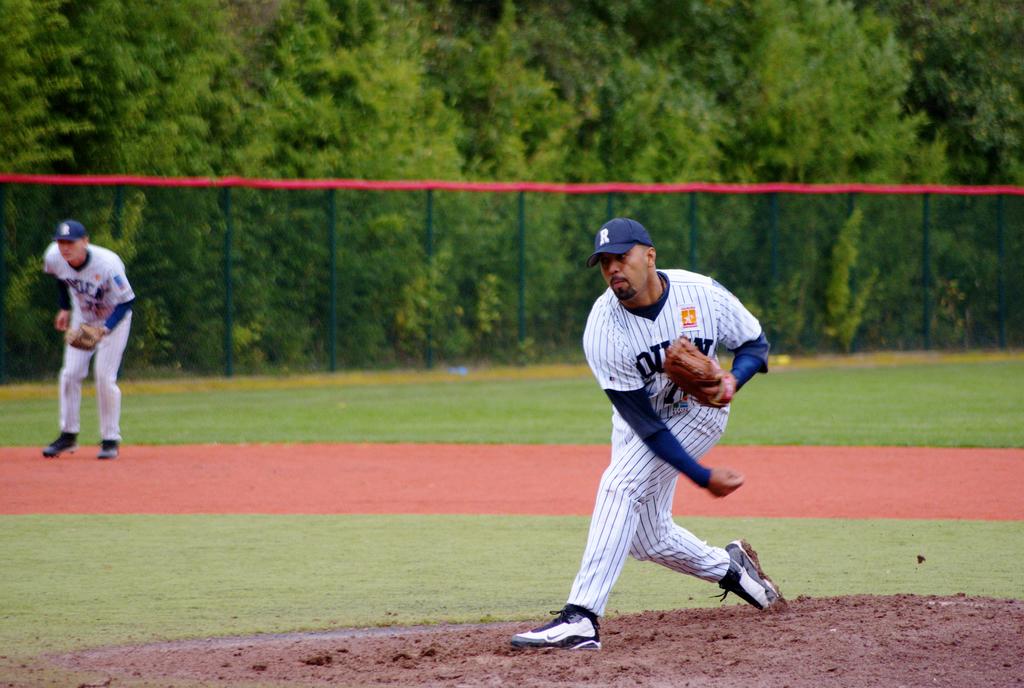What is written on the pitchers cap?
Ensure brevity in your answer.  R. Is the letter on the pitchers cap a capitol letter?
Ensure brevity in your answer.  Yes. 